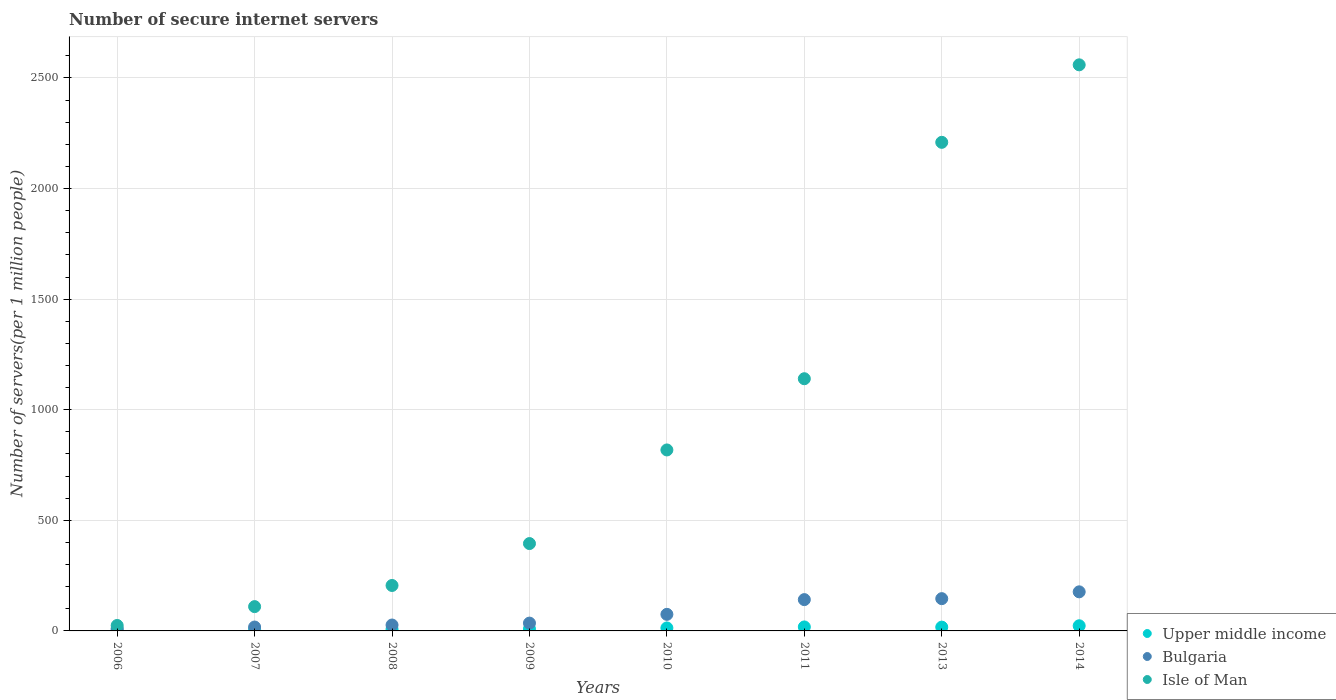How many different coloured dotlines are there?
Give a very brief answer. 3. What is the number of secure internet servers in Isle of Man in 2010?
Your answer should be compact. 818.24. Across all years, what is the maximum number of secure internet servers in Isle of Man?
Keep it short and to the point. 2559.48. Across all years, what is the minimum number of secure internet servers in Bulgaria?
Provide a succinct answer. 11.17. In which year was the number of secure internet servers in Isle of Man maximum?
Offer a very short reply. 2014. What is the total number of secure internet servers in Bulgaria in the graph?
Provide a succinct answer. 629.88. What is the difference between the number of secure internet servers in Bulgaria in 2011 and that in 2014?
Provide a short and direct response. -35.19. What is the difference between the number of secure internet servers in Bulgaria in 2013 and the number of secure internet servers in Upper middle income in 2008?
Your answer should be compact. 137.87. What is the average number of secure internet servers in Upper middle income per year?
Give a very brief answer. 12.51. In the year 2014, what is the difference between the number of secure internet servers in Bulgaria and number of secure internet servers in Isle of Man?
Give a very brief answer. -2382.77. What is the ratio of the number of secure internet servers in Upper middle income in 2006 to that in 2014?
Offer a terse response. 0.2. What is the difference between the highest and the second highest number of secure internet servers in Isle of Man?
Your answer should be very brief. 350.42. What is the difference between the highest and the lowest number of secure internet servers in Upper middle income?
Ensure brevity in your answer.  18.7. Is the sum of the number of secure internet servers in Isle of Man in 2007 and 2009 greater than the maximum number of secure internet servers in Bulgaria across all years?
Offer a terse response. Yes. Is it the case that in every year, the sum of the number of secure internet servers in Upper middle income and number of secure internet servers in Isle of Man  is greater than the number of secure internet servers in Bulgaria?
Make the answer very short. Yes. Is the number of secure internet servers in Isle of Man strictly greater than the number of secure internet servers in Upper middle income over the years?
Ensure brevity in your answer.  Yes. How many dotlines are there?
Provide a succinct answer. 3. How many years are there in the graph?
Make the answer very short. 8. What is the difference between two consecutive major ticks on the Y-axis?
Ensure brevity in your answer.  500. Does the graph contain any zero values?
Provide a succinct answer. No. Where does the legend appear in the graph?
Give a very brief answer. Bottom right. What is the title of the graph?
Provide a short and direct response. Number of secure internet servers. What is the label or title of the X-axis?
Give a very brief answer. Years. What is the label or title of the Y-axis?
Ensure brevity in your answer.  Number of servers(per 1 million people). What is the Number of servers(per 1 million people) of Upper middle income in 2006?
Offer a terse response. 4.6. What is the Number of servers(per 1 million people) in Bulgaria in 2006?
Your response must be concise. 11.17. What is the Number of servers(per 1 million people) of Isle of Man in 2006?
Offer a very short reply. 24.66. What is the Number of servers(per 1 million people) in Upper middle income in 2007?
Keep it short and to the point. 6.38. What is the Number of servers(per 1 million people) of Bulgaria in 2007?
Your answer should be very brief. 17.63. What is the Number of servers(per 1 million people) of Isle of Man in 2007?
Keep it short and to the point. 109.87. What is the Number of servers(per 1 million people) of Upper middle income in 2008?
Keep it short and to the point. 8.03. What is the Number of servers(per 1 million people) in Bulgaria in 2008?
Offer a terse response. 26.69. What is the Number of servers(per 1 million people) in Isle of Man in 2008?
Give a very brief answer. 205.47. What is the Number of servers(per 1 million people) of Upper middle income in 2009?
Keep it short and to the point. 9.16. What is the Number of servers(per 1 million people) in Bulgaria in 2009?
Your response must be concise. 35.33. What is the Number of servers(per 1 million people) in Isle of Man in 2009?
Your answer should be compact. 394.98. What is the Number of servers(per 1 million people) of Upper middle income in 2010?
Offer a terse response. 13.42. What is the Number of servers(per 1 million people) of Bulgaria in 2010?
Ensure brevity in your answer.  74.91. What is the Number of servers(per 1 million people) of Isle of Man in 2010?
Offer a very short reply. 818.24. What is the Number of servers(per 1 million people) of Upper middle income in 2011?
Give a very brief answer. 18.02. What is the Number of servers(per 1 million people) in Bulgaria in 2011?
Provide a succinct answer. 141.53. What is the Number of servers(per 1 million people) in Isle of Man in 2011?
Provide a succinct answer. 1140.25. What is the Number of servers(per 1 million people) of Upper middle income in 2013?
Make the answer very short. 17.16. What is the Number of servers(per 1 million people) in Bulgaria in 2013?
Offer a very short reply. 145.9. What is the Number of servers(per 1 million people) in Isle of Man in 2013?
Make the answer very short. 2209.06. What is the Number of servers(per 1 million people) in Upper middle income in 2014?
Offer a terse response. 23.3. What is the Number of servers(per 1 million people) in Bulgaria in 2014?
Keep it short and to the point. 176.72. What is the Number of servers(per 1 million people) of Isle of Man in 2014?
Give a very brief answer. 2559.48. Across all years, what is the maximum Number of servers(per 1 million people) in Upper middle income?
Ensure brevity in your answer.  23.3. Across all years, what is the maximum Number of servers(per 1 million people) in Bulgaria?
Your answer should be compact. 176.72. Across all years, what is the maximum Number of servers(per 1 million people) of Isle of Man?
Ensure brevity in your answer.  2559.48. Across all years, what is the minimum Number of servers(per 1 million people) in Upper middle income?
Give a very brief answer. 4.6. Across all years, what is the minimum Number of servers(per 1 million people) in Bulgaria?
Provide a succinct answer. 11.17. Across all years, what is the minimum Number of servers(per 1 million people) of Isle of Man?
Keep it short and to the point. 24.66. What is the total Number of servers(per 1 million people) in Upper middle income in the graph?
Make the answer very short. 100.08. What is the total Number of servers(per 1 million people) in Bulgaria in the graph?
Provide a short and direct response. 629.88. What is the total Number of servers(per 1 million people) of Isle of Man in the graph?
Provide a succinct answer. 7462.02. What is the difference between the Number of servers(per 1 million people) in Upper middle income in 2006 and that in 2007?
Your answer should be very brief. -1.78. What is the difference between the Number of servers(per 1 million people) in Bulgaria in 2006 and that in 2007?
Ensure brevity in your answer.  -6.46. What is the difference between the Number of servers(per 1 million people) in Isle of Man in 2006 and that in 2007?
Give a very brief answer. -85.21. What is the difference between the Number of servers(per 1 million people) of Upper middle income in 2006 and that in 2008?
Provide a succinct answer. -3.43. What is the difference between the Number of servers(per 1 million people) in Bulgaria in 2006 and that in 2008?
Your answer should be very brief. -15.52. What is the difference between the Number of servers(per 1 million people) of Isle of Man in 2006 and that in 2008?
Offer a terse response. -180.81. What is the difference between the Number of servers(per 1 million people) of Upper middle income in 2006 and that in 2009?
Keep it short and to the point. -4.56. What is the difference between the Number of servers(per 1 million people) of Bulgaria in 2006 and that in 2009?
Provide a short and direct response. -24.16. What is the difference between the Number of servers(per 1 million people) of Isle of Man in 2006 and that in 2009?
Provide a short and direct response. -370.32. What is the difference between the Number of servers(per 1 million people) in Upper middle income in 2006 and that in 2010?
Give a very brief answer. -8.82. What is the difference between the Number of servers(per 1 million people) of Bulgaria in 2006 and that in 2010?
Give a very brief answer. -63.74. What is the difference between the Number of servers(per 1 million people) in Isle of Man in 2006 and that in 2010?
Ensure brevity in your answer.  -793.59. What is the difference between the Number of servers(per 1 million people) of Upper middle income in 2006 and that in 2011?
Ensure brevity in your answer.  -13.42. What is the difference between the Number of servers(per 1 million people) in Bulgaria in 2006 and that in 2011?
Keep it short and to the point. -130.36. What is the difference between the Number of servers(per 1 million people) of Isle of Man in 2006 and that in 2011?
Your response must be concise. -1115.59. What is the difference between the Number of servers(per 1 million people) of Upper middle income in 2006 and that in 2013?
Offer a terse response. -12.56. What is the difference between the Number of servers(per 1 million people) in Bulgaria in 2006 and that in 2013?
Your response must be concise. -134.73. What is the difference between the Number of servers(per 1 million people) in Isle of Man in 2006 and that in 2013?
Your answer should be very brief. -2184.41. What is the difference between the Number of servers(per 1 million people) of Upper middle income in 2006 and that in 2014?
Your answer should be compact. -18.7. What is the difference between the Number of servers(per 1 million people) in Bulgaria in 2006 and that in 2014?
Ensure brevity in your answer.  -165.55. What is the difference between the Number of servers(per 1 million people) of Isle of Man in 2006 and that in 2014?
Your response must be concise. -2534.82. What is the difference between the Number of servers(per 1 million people) of Upper middle income in 2007 and that in 2008?
Make the answer very short. -1.65. What is the difference between the Number of servers(per 1 million people) of Bulgaria in 2007 and that in 2008?
Make the answer very short. -9.07. What is the difference between the Number of servers(per 1 million people) of Isle of Man in 2007 and that in 2008?
Give a very brief answer. -95.6. What is the difference between the Number of servers(per 1 million people) of Upper middle income in 2007 and that in 2009?
Make the answer very short. -2.78. What is the difference between the Number of servers(per 1 million people) of Bulgaria in 2007 and that in 2009?
Keep it short and to the point. -17.7. What is the difference between the Number of servers(per 1 million people) in Isle of Man in 2007 and that in 2009?
Provide a short and direct response. -285.11. What is the difference between the Number of servers(per 1 million people) in Upper middle income in 2007 and that in 2010?
Keep it short and to the point. -7.04. What is the difference between the Number of servers(per 1 million people) in Bulgaria in 2007 and that in 2010?
Your response must be concise. -57.28. What is the difference between the Number of servers(per 1 million people) of Isle of Man in 2007 and that in 2010?
Provide a succinct answer. -708.37. What is the difference between the Number of servers(per 1 million people) in Upper middle income in 2007 and that in 2011?
Provide a succinct answer. -11.64. What is the difference between the Number of servers(per 1 million people) of Bulgaria in 2007 and that in 2011?
Ensure brevity in your answer.  -123.9. What is the difference between the Number of servers(per 1 million people) of Isle of Man in 2007 and that in 2011?
Give a very brief answer. -1030.38. What is the difference between the Number of servers(per 1 million people) in Upper middle income in 2007 and that in 2013?
Your answer should be very brief. -10.78. What is the difference between the Number of servers(per 1 million people) in Bulgaria in 2007 and that in 2013?
Keep it short and to the point. -128.28. What is the difference between the Number of servers(per 1 million people) of Isle of Man in 2007 and that in 2013?
Give a very brief answer. -2099.19. What is the difference between the Number of servers(per 1 million people) in Upper middle income in 2007 and that in 2014?
Make the answer very short. -16.92. What is the difference between the Number of servers(per 1 million people) of Bulgaria in 2007 and that in 2014?
Give a very brief answer. -159.09. What is the difference between the Number of servers(per 1 million people) of Isle of Man in 2007 and that in 2014?
Keep it short and to the point. -2449.61. What is the difference between the Number of servers(per 1 million people) of Upper middle income in 2008 and that in 2009?
Give a very brief answer. -1.13. What is the difference between the Number of servers(per 1 million people) of Bulgaria in 2008 and that in 2009?
Provide a short and direct response. -8.64. What is the difference between the Number of servers(per 1 million people) in Isle of Man in 2008 and that in 2009?
Give a very brief answer. -189.51. What is the difference between the Number of servers(per 1 million people) of Upper middle income in 2008 and that in 2010?
Give a very brief answer. -5.39. What is the difference between the Number of servers(per 1 million people) of Bulgaria in 2008 and that in 2010?
Your answer should be very brief. -48.22. What is the difference between the Number of servers(per 1 million people) of Isle of Man in 2008 and that in 2010?
Provide a succinct answer. -612.77. What is the difference between the Number of servers(per 1 million people) in Upper middle income in 2008 and that in 2011?
Your response must be concise. -9.99. What is the difference between the Number of servers(per 1 million people) of Bulgaria in 2008 and that in 2011?
Give a very brief answer. -114.84. What is the difference between the Number of servers(per 1 million people) in Isle of Man in 2008 and that in 2011?
Provide a succinct answer. -934.78. What is the difference between the Number of servers(per 1 million people) of Upper middle income in 2008 and that in 2013?
Offer a very short reply. -9.12. What is the difference between the Number of servers(per 1 million people) of Bulgaria in 2008 and that in 2013?
Keep it short and to the point. -119.21. What is the difference between the Number of servers(per 1 million people) of Isle of Man in 2008 and that in 2013?
Offer a very short reply. -2003.59. What is the difference between the Number of servers(per 1 million people) in Upper middle income in 2008 and that in 2014?
Offer a terse response. -15.27. What is the difference between the Number of servers(per 1 million people) in Bulgaria in 2008 and that in 2014?
Your answer should be very brief. -150.02. What is the difference between the Number of servers(per 1 million people) in Isle of Man in 2008 and that in 2014?
Keep it short and to the point. -2354.01. What is the difference between the Number of servers(per 1 million people) of Upper middle income in 2009 and that in 2010?
Offer a terse response. -4.26. What is the difference between the Number of servers(per 1 million people) of Bulgaria in 2009 and that in 2010?
Provide a short and direct response. -39.58. What is the difference between the Number of servers(per 1 million people) in Isle of Man in 2009 and that in 2010?
Your answer should be very brief. -423.26. What is the difference between the Number of servers(per 1 million people) of Upper middle income in 2009 and that in 2011?
Your answer should be very brief. -8.86. What is the difference between the Number of servers(per 1 million people) in Bulgaria in 2009 and that in 2011?
Keep it short and to the point. -106.2. What is the difference between the Number of servers(per 1 million people) of Isle of Man in 2009 and that in 2011?
Make the answer very short. -745.27. What is the difference between the Number of servers(per 1 million people) of Upper middle income in 2009 and that in 2013?
Offer a terse response. -7.99. What is the difference between the Number of servers(per 1 million people) of Bulgaria in 2009 and that in 2013?
Keep it short and to the point. -110.57. What is the difference between the Number of servers(per 1 million people) in Isle of Man in 2009 and that in 2013?
Keep it short and to the point. -1814.08. What is the difference between the Number of servers(per 1 million people) in Upper middle income in 2009 and that in 2014?
Offer a terse response. -14.14. What is the difference between the Number of servers(per 1 million people) of Bulgaria in 2009 and that in 2014?
Provide a succinct answer. -141.39. What is the difference between the Number of servers(per 1 million people) in Isle of Man in 2009 and that in 2014?
Ensure brevity in your answer.  -2164.5. What is the difference between the Number of servers(per 1 million people) of Upper middle income in 2010 and that in 2011?
Your answer should be compact. -4.6. What is the difference between the Number of servers(per 1 million people) in Bulgaria in 2010 and that in 2011?
Make the answer very short. -66.62. What is the difference between the Number of servers(per 1 million people) of Isle of Man in 2010 and that in 2011?
Offer a terse response. -322.01. What is the difference between the Number of servers(per 1 million people) of Upper middle income in 2010 and that in 2013?
Provide a succinct answer. -3.73. What is the difference between the Number of servers(per 1 million people) of Bulgaria in 2010 and that in 2013?
Ensure brevity in your answer.  -70.99. What is the difference between the Number of servers(per 1 million people) in Isle of Man in 2010 and that in 2013?
Keep it short and to the point. -1390.82. What is the difference between the Number of servers(per 1 million people) in Upper middle income in 2010 and that in 2014?
Give a very brief answer. -9.88. What is the difference between the Number of servers(per 1 million people) of Bulgaria in 2010 and that in 2014?
Make the answer very short. -101.81. What is the difference between the Number of servers(per 1 million people) of Isle of Man in 2010 and that in 2014?
Give a very brief answer. -1741.24. What is the difference between the Number of servers(per 1 million people) of Upper middle income in 2011 and that in 2013?
Your answer should be compact. 0.86. What is the difference between the Number of servers(per 1 million people) in Bulgaria in 2011 and that in 2013?
Your answer should be very brief. -4.37. What is the difference between the Number of servers(per 1 million people) of Isle of Man in 2011 and that in 2013?
Give a very brief answer. -1068.81. What is the difference between the Number of servers(per 1 million people) in Upper middle income in 2011 and that in 2014?
Ensure brevity in your answer.  -5.28. What is the difference between the Number of servers(per 1 million people) of Bulgaria in 2011 and that in 2014?
Your response must be concise. -35.19. What is the difference between the Number of servers(per 1 million people) of Isle of Man in 2011 and that in 2014?
Provide a succinct answer. -1419.23. What is the difference between the Number of servers(per 1 million people) in Upper middle income in 2013 and that in 2014?
Your response must be concise. -6.14. What is the difference between the Number of servers(per 1 million people) of Bulgaria in 2013 and that in 2014?
Keep it short and to the point. -30.81. What is the difference between the Number of servers(per 1 million people) of Isle of Man in 2013 and that in 2014?
Provide a succinct answer. -350.42. What is the difference between the Number of servers(per 1 million people) in Upper middle income in 2006 and the Number of servers(per 1 million people) in Bulgaria in 2007?
Offer a terse response. -13.03. What is the difference between the Number of servers(per 1 million people) in Upper middle income in 2006 and the Number of servers(per 1 million people) in Isle of Man in 2007?
Give a very brief answer. -105.27. What is the difference between the Number of servers(per 1 million people) in Bulgaria in 2006 and the Number of servers(per 1 million people) in Isle of Man in 2007?
Provide a succinct answer. -98.7. What is the difference between the Number of servers(per 1 million people) of Upper middle income in 2006 and the Number of servers(per 1 million people) of Bulgaria in 2008?
Keep it short and to the point. -22.09. What is the difference between the Number of servers(per 1 million people) in Upper middle income in 2006 and the Number of servers(per 1 million people) in Isle of Man in 2008?
Your answer should be compact. -200.87. What is the difference between the Number of servers(per 1 million people) in Bulgaria in 2006 and the Number of servers(per 1 million people) in Isle of Man in 2008?
Your answer should be very brief. -194.3. What is the difference between the Number of servers(per 1 million people) of Upper middle income in 2006 and the Number of servers(per 1 million people) of Bulgaria in 2009?
Ensure brevity in your answer.  -30.73. What is the difference between the Number of servers(per 1 million people) of Upper middle income in 2006 and the Number of servers(per 1 million people) of Isle of Man in 2009?
Offer a terse response. -390.38. What is the difference between the Number of servers(per 1 million people) in Bulgaria in 2006 and the Number of servers(per 1 million people) in Isle of Man in 2009?
Your answer should be compact. -383.81. What is the difference between the Number of servers(per 1 million people) in Upper middle income in 2006 and the Number of servers(per 1 million people) in Bulgaria in 2010?
Keep it short and to the point. -70.31. What is the difference between the Number of servers(per 1 million people) in Upper middle income in 2006 and the Number of servers(per 1 million people) in Isle of Man in 2010?
Provide a succinct answer. -813.64. What is the difference between the Number of servers(per 1 million people) of Bulgaria in 2006 and the Number of servers(per 1 million people) of Isle of Man in 2010?
Ensure brevity in your answer.  -807.07. What is the difference between the Number of servers(per 1 million people) in Upper middle income in 2006 and the Number of servers(per 1 million people) in Bulgaria in 2011?
Make the answer very short. -136.93. What is the difference between the Number of servers(per 1 million people) of Upper middle income in 2006 and the Number of servers(per 1 million people) of Isle of Man in 2011?
Make the answer very short. -1135.65. What is the difference between the Number of servers(per 1 million people) of Bulgaria in 2006 and the Number of servers(per 1 million people) of Isle of Man in 2011?
Make the answer very short. -1129.08. What is the difference between the Number of servers(per 1 million people) of Upper middle income in 2006 and the Number of servers(per 1 million people) of Bulgaria in 2013?
Keep it short and to the point. -141.3. What is the difference between the Number of servers(per 1 million people) in Upper middle income in 2006 and the Number of servers(per 1 million people) in Isle of Man in 2013?
Offer a terse response. -2204.46. What is the difference between the Number of servers(per 1 million people) in Bulgaria in 2006 and the Number of servers(per 1 million people) in Isle of Man in 2013?
Make the answer very short. -2197.89. What is the difference between the Number of servers(per 1 million people) of Upper middle income in 2006 and the Number of servers(per 1 million people) of Bulgaria in 2014?
Keep it short and to the point. -172.12. What is the difference between the Number of servers(per 1 million people) of Upper middle income in 2006 and the Number of servers(per 1 million people) of Isle of Man in 2014?
Provide a short and direct response. -2554.88. What is the difference between the Number of servers(per 1 million people) of Bulgaria in 2006 and the Number of servers(per 1 million people) of Isle of Man in 2014?
Offer a terse response. -2548.31. What is the difference between the Number of servers(per 1 million people) of Upper middle income in 2007 and the Number of servers(per 1 million people) of Bulgaria in 2008?
Give a very brief answer. -20.31. What is the difference between the Number of servers(per 1 million people) in Upper middle income in 2007 and the Number of servers(per 1 million people) in Isle of Man in 2008?
Provide a short and direct response. -199.09. What is the difference between the Number of servers(per 1 million people) in Bulgaria in 2007 and the Number of servers(per 1 million people) in Isle of Man in 2008?
Give a very brief answer. -187.84. What is the difference between the Number of servers(per 1 million people) of Upper middle income in 2007 and the Number of servers(per 1 million people) of Bulgaria in 2009?
Your answer should be compact. -28.95. What is the difference between the Number of servers(per 1 million people) of Upper middle income in 2007 and the Number of servers(per 1 million people) of Isle of Man in 2009?
Your response must be concise. -388.6. What is the difference between the Number of servers(per 1 million people) in Bulgaria in 2007 and the Number of servers(per 1 million people) in Isle of Man in 2009?
Your response must be concise. -377.36. What is the difference between the Number of servers(per 1 million people) of Upper middle income in 2007 and the Number of servers(per 1 million people) of Bulgaria in 2010?
Your response must be concise. -68.53. What is the difference between the Number of servers(per 1 million people) of Upper middle income in 2007 and the Number of servers(per 1 million people) of Isle of Man in 2010?
Provide a short and direct response. -811.86. What is the difference between the Number of servers(per 1 million people) of Bulgaria in 2007 and the Number of servers(per 1 million people) of Isle of Man in 2010?
Provide a short and direct response. -800.62. What is the difference between the Number of servers(per 1 million people) in Upper middle income in 2007 and the Number of servers(per 1 million people) in Bulgaria in 2011?
Offer a terse response. -135.15. What is the difference between the Number of servers(per 1 million people) of Upper middle income in 2007 and the Number of servers(per 1 million people) of Isle of Man in 2011?
Provide a succinct answer. -1133.87. What is the difference between the Number of servers(per 1 million people) in Bulgaria in 2007 and the Number of servers(per 1 million people) in Isle of Man in 2011?
Give a very brief answer. -1122.62. What is the difference between the Number of servers(per 1 million people) of Upper middle income in 2007 and the Number of servers(per 1 million people) of Bulgaria in 2013?
Make the answer very short. -139.52. What is the difference between the Number of servers(per 1 million people) in Upper middle income in 2007 and the Number of servers(per 1 million people) in Isle of Man in 2013?
Your response must be concise. -2202.68. What is the difference between the Number of servers(per 1 million people) in Bulgaria in 2007 and the Number of servers(per 1 million people) in Isle of Man in 2013?
Ensure brevity in your answer.  -2191.44. What is the difference between the Number of servers(per 1 million people) in Upper middle income in 2007 and the Number of servers(per 1 million people) in Bulgaria in 2014?
Your answer should be compact. -170.34. What is the difference between the Number of servers(per 1 million people) of Upper middle income in 2007 and the Number of servers(per 1 million people) of Isle of Man in 2014?
Offer a terse response. -2553.1. What is the difference between the Number of servers(per 1 million people) of Bulgaria in 2007 and the Number of servers(per 1 million people) of Isle of Man in 2014?
Provide a short and direct response. -2541.86. What is the difference between the Number of servers(per 1 million people) in Upper middle income in 2008 and the Number of servers(per 1 million people) in Bulgaria in 2009?
Provide a short and direct response. -27.29. What is the difference between the Number of servers(per 1 million people) in Upper middle income in 2008 and the Number of servers(per 1 million people) in Isle of Man in 2009?
Your response must be concise. -386.95. What is the difference between the Number of servers(per 1 million people) of Bulgaria in 2008 and the Number of servers(per 1 million people) of Isle of Man in 2009?
Provide a succinct answer. -368.29. What is the difference between the Number of servers(per 1 million people) of Upper middle income in 2008 and the Number of servers(per 1 million people) of Bulgaria in 2010?
Your answer should be very brief. -66.87. What is the difference between the Number of servers(per 1 million people) of Upper middle income in 2008 and the Number of servers(per 1 million people) of Isle of Man in 2010?
Offer a terse response. -810.21. What is the difference between the Number of servers(per 1 million people) of Bulgaria in 2008 and the Number of servers(per 1 million people) of Isle of Man in 2010?
Your answer should be very brief. -791.55. What is the difference between the Number of servers(per 1 million people) of Upper middle income in 2008 and the Number of servers(per 1 million people) of Bulgaria in 2011?
Your response must be concise. -133.49. What is the difference between the Number of servers(per 1 million people) of Upper middle income in 2008 and the Number of servers(per 1 million people) of Isle of Man in 2011?
Keep it short and to the point. -1132.22. What is the difference between the Number of servers(per 1 million people) of Bulgaria in 2008 and the Number of servers(per 1 million people) of Isle of Man in 2011?
Keep it short and to the point. -1113.56. What is the difference between the Number of servers(per 1 million people) of Upper middle income in 2008 and the Number of servers(per 1 million people) of Bulgaria in 2013?
Ensure brevity in your answer.  -137.87. What is the difference between the Number of servers(per 1 million people) of Upper middle income in 2008 and the Number of servers(per 1 million people) of Isle of Man in 2013?
Offer a very short reply. -2201.03. What is the difference between the Number of servers(per 1 million people) of Bulgaria in 2008 and the Number of servers(per 1 million people) of Isle of Man in 2013?
Provide a succinct answer. -2182.37. What is the difference between the Number of servers(per 1 million people) of Upper middle income in 2008 and the Number of servers(per 1 million people) of Bulgaria in 2014?
Keep it short and to the point. -168.68. What is the difference between the Number of servers(per 1 million people) in Upper middle income in 2008 and the Number of servers(per 1 million people) in Isle of Man in 2014?
Your answer should be compact. -2551.45. What is the difference between the Number of servers(per 1 million people) in Bulgaria in 2008 and the Number of servers(per 1 million people) in Isle of Man in 2014?
Provide a succinct answer. -2532.79. What is the difference between the Number of servers(per 1 million people) of Upper middle income in 2009 and the Number of servers(per 1 million people) of Bulgaria in 2010?
Provide a succinct answer. -65.75. What is the difference between the Number of servers(per 1 million people) in Upper middle income in 2009 and the Number of servers(per 1 million people) in Isle of Man in 2010?
Ensure brevity in your answer.  -809.08. What is the difference between the Number of servers(per 1 million people) of Bulgaria in 2009 and the Number of servers(per 1 million people) of Isle of Man in 2010?
Your answer should be compact. -782.91. What is the difference between the Number of servers(per 1 million people) in Upper middle income in 2009 and the Number of servers(per 1 million people) in Bulgaria in 2011?
Provide a succinct answer. -132.37. What is the difference between the Number of servers(per 1 million people) in Upper middle income in 2009 and the Number of servers(per 1 million people) in Isle of Man in 2011?
Provide a short and direct response. -1131.09. What is the difference between the Number of servers(per 1 million people) of Bulgaria in 2009 and the Number of servers(per 1 million people) of Isle of Man in 2011?
Provide a succinct answer. -1104.92. What is the difference between the Number of servers(per 1 million people) in Upper middle income in 2009 and the Number of servers(per 1 million people) in Bulgaria in 2013?
Ensure brevity in your answer.  -136.74. What is the difference between the Number of servers(per 1 million people) in Upper middle income in 2009 and the Number of servers(per 1 million people) in Isle of Man in 2013?
Provide a short and direct response. -2199.9. What is the difference between the Number of servers(per 1 million people) of Bulgaria in 2009 and the Number of servers(per 1 million people) of Isle of Man in 2013?
Give a very brief answer. -2173.73. What is the difference between the Number of servers(per 1 million people) in Upper middle income in 2009 and the Number of servers(per 1 million people) in Bulgaria in 2014?
Offer a very short reply. -167.55. What is the difference between the Number of servers(per 1 million people) in Upper middle income in 2009 and the Number of servers(per 1 million people) in Isle of Man in 2014?
Give a very brief answer. -2550.32. What is the difference between the Number of servers(per 1 million people) in Bulgaria in 2009 and the Number of servers(per 1 million people) in Isle of Man in 2014?
Your answer should be very brief. -2524.15. What is the difference between the Number of servers(per 1 million people) of Upper middle income in 2010 and the Number of servers(per 1 million people) of Bulgaria in 2011?
Offer a very short reply. -128.11. What is the difference between the Number of servers(per 1 million people) in Upper middle income in 2010 and the Number of servers(per 1 million people) in Isle of Man in 2011?
Your response must be concise. -1126.83. What is the difference between the Number of servers(per 1 million people) of Bulgaria in 2010 and the Number of servers(per 1 million people) of Isle of Man in 2011?
Your response must be concise. -1065.34. What is the difference between the Number of servers(per 1 million people) of Upper middle income in 2010 and the Number of servers(per 1 million people) of Bulgaria in 2013?
Make the answer very short. -132.48. What is the difference between the Number of servers(per 1 million people) in Upper middle income in 2010 and the Number of servers(per 1 million people) in Isle of Man in 2013?
Keep it short and to the point. -2195.64. What is the difference between the Number of servers(per 1 million people) in Bulgaria in 2010 and the Number of servers(per 1 million people) in Isle of Man in 2013?
Make the answer very short. -2134.15. What is the difference between the Number of servers(per 1 million people) in Upper middle income in 2010 and the Number of servers(per 1 million people) in Bulgaria in 2014?
Your answer should be compact. -163.29. What is the difference between the Number of servers(per 1 million people) in Upper middle income in 2010 and the Number of servers(per 1 million people) in Isle of Man in 2014?
Provide a short and direct response. -2546.06. What is the difference between the Number of servers(per 1 million people) of Bulgaria in 2010 and the Number of servers(per 1 million people) of Isle of Man in 2014?
Provide a succinct answer. -2484.57. What is the difference between the Number of servers(per 1 million people) in Upper middle income in 2011 and the Number of servers(per 1 million people) in Bulgaria in 2013?
Offer a very short reply. -127.88. What is the difference between the Number of servers(per 1 million people) in Upper middle income in 2011 and the Number of servers(per 1 million people) in Isle of Man in 2013?
Offer a terse response. -2191.04. What is the difference between the Number of servers(per 1 million people) of Bulgaria in 2011 and the Number of servers(per 1 million people) of Isle of Man in 2013?
Provide a succinct answer. -2067.53. What is the difference between the Number of servers(per 1 million people) in Upper middle income in 2011 and the Number of servers(per 1 million people) in Bulgaria in 2014?
Your answer should be compact. -158.7. What is the difference between the Number of servers(per 1 million people) in Upper middle income in 2011 and the Number of servers(per 1 million people) in Isle of Man in 2014?
Provide a succinct answer. -2541.46. What is the difference between the Number of servers(per 1 million people) of Bulgaria in 2011 and the Number of servers(per 1 million people) of Isle of Man in 2014?
Give a very brief answer. -2417.95. What is the difference between the Number of servers(per 1 million people) of Upper middle income in 2013 and the Number of servers(per 1 million people) of Bulgaria in 2014?
Offer a terse response. -159.56. What is the difference between the Number of servers(per 1 million people) in Upper middle income in 2013 and the Number of servers(per 1 million people) in Isle of Man in 2014?
Give a very brief answer. -2542.33. What is the difference between the Number of servers(per 1 million people) of Bulgaria in 2013 and the Number of servers(per 1 million people) of Isle of Man in 2014?
Give a very brief answer. -2413.58. What is the average Number of servers(per 1 million people) in Upper middle income per year?
Make the answer very short. 12.51. What is the average Number of servers(per 1 million people) in Bulgaria per year?
Your answer should be compact. 78.73. What is the average Number of servers(per 1 million people) of Isle of Man per year?
Provide a succinct answer. 932.75. In the year 2006, what is the difference between the Number of servers(per 1 million people) of Upper middle income and Number of servers(per 1 million people) of Bulgaria?
Provide a short and direct response. -6.57. In the year 2006, what is the difference between the Number of servers(per 1 million people) in Upper middle income and Number of servers(per 1 million people) in Isle of Man?
Your response must be concise. -20.06. In the year 2006, what is the difference between the Number of servers(per 1 million people) of Bulgaria and Number of servers(per 1 million people) of Isle of Man?
Offer a terse response. -13.49. In the year 2007, what is the difference between the Number of servers(per 1 million people) of Upper middle income and Number of servers(per 1 million people) of Bulgaria?
Your answer should be compact. -11.25. In the year 2007, what is the difference between the Number of servers(per 1 million people) of Upper middle income and Number of servers(per 1 million people) of Isle of Man?
Offer a terse response. -103.49. In the year 2007, what is the difference between the Number of servers(per 1 million people) of Bulgaria and Number of servers(per 1 million people) of Isle of Man?
Provide a succinct answer. -92.24. In the year 2008, what is the difference between the Number of servers(per 1 million people) in Upper middle income and Number of servers(per 1 million people) in Bulgaria?
Give a very brief answer. -18.66. In the year 2008, what is the difference between the Number of servers(per 1 million people) of Upper middle income and Number of servers(per 1 million people) of Isle of Man?
Provide a succinct answer. -197.44. In the year 2008, what is the difference between the Number of servers(per 1 million people) in Bulgaria and Number of servers(per 1 million people) in Isle of Man?
Give a very brief answer. -178.78. In the year 2009, what is the difference between the Number of servers(per 1 million people) of Upper middle income and Number of servers(per 1 million people) of Bulgaria?
Provide a short and direct response. -26.17. In the year 2009, what is the difference between the Number of servers(per 1 million people) in Upper middle income and Number of servers(per 1 million people) in Isle of Man?
Offer a very short reply. -385.82. In the year 2009, what is the difference between the Number of servers(per 1 million people) of Bulgaria and Number of servers(per 1 million people) of Isle of Man?
Provide a short and direct response. -359.65. In the year 2010, what is the difference between the Number of servers(per 1 million people) of Upper middle income and Number of servers(per 1 million people) of Bulgaria?
Your answer should be very brief. -61.49. In the year 2010, what is the difference between the Number of servers(per 1 million people) of Upper middle income and Number of servers(per 1 million people) of Isle of Man?
Provide a succinct answer. -804.82. In the year 2010, what is the difference between the Number of servers(per 1 million people) of Bulgaria and Number of servers(per 1 million people) of Isle of Man?
Make the answer very short. -743.33. In the year 2011, what is the difference between the Number of servers(per 1 million people) of Upper middle income and Number of servers(per 1 million people) of Bulgaria?
Ensure brevity in your answer.  -123.51. In the year 2011, what is the difference between the Number of servers(per 1 million people) in Upper middle income and Number of servers(per 1 million people) in Isle of Man?
Give a very brief answer. -1122.23. In the year 2011, what is the difference between the Number of servers(per 1 million people) of Bulgaria and Number of servers(per 1 million people) of Isle of Man?
Ensure brevity in your answer.  -998.72. In the year 2013, what is the difference between the Number of servers(per 1 million people) in Upper middle income and Number of servers(per 1 million people) in Bulgaria?
Provide a succinct answer. -128.75. In the year 2013, what is the difference between the Number of servers(per 1 million people) of Upper middle income and Number of servers(per 1 million people) of Isle of Man?
Keep it short and to the point. -2191.91. In the year 2013, what is the difference between the Number of servers(per 1 million people) in Bulgaria and Number of servers(per 1 million people) in Isle of Man?
Your answer should be very brief. -2063.16. In the year 2014, what is the difference between the Number of servers(per 1 million people) of Upper middle income and Number of servers(per 1 million people) of Bulgaria?
Keep it short and to the point. -153.42. In the year 2014, what is the difference between the Number of servers(per 1 million people) of Upper middle income and Number of servers(per 1 million people) of Isle of Man?
Your answer should be very brief. -2536.18. In the year 2014, what is the difference between the Number of servers(per 1 million people) in Bulgaria and Number of servers(per 1 million people) in Isle of Man?
Keep it short and to the point. -2382.77. What is the ratio of the Number of servers(per 1 million people) in Upper middle income in 2006 to that in 2007?
Offer a terse response. 0.72. What is the ratio of the Number of servers(per 1 million people) in Bulgaria in 2006 to that in 2007?
Keep it short and to the point. 0.63. What is the ratio of the Number of servers(per 1 million people) in Isle of Man in 2006 to that in 2007?
Offer a terse response. 0.22. What is the ratio of the Number of servers(per 1 million people) in Upper middle income in 2006 to that in 2008?
Give a very brief answer. 0.57. What is the ratio of the Number of servers(per 1 million people) of Bulgaria in 2006 to that in 2008?
Provide a short and direct response. 0.42. What is the ratio of the Number of servers(per 1 million people) of Isle of Man in 2006 to that in 2008?
Ensure brevity in your answer.  0.12. What is the ratio of the Number of servers(per 1 million people) of Upper middle income in 2006 to that in 2009?
Offer a very short reply. 0.5. What is the ratio of the Number of servers(per 1 million people) in Bulgaria in 2006 to that in 2009?
Your answer should be compact. 0.32. What is the ratio of the Number of servers(per 1 million people) in Isle of Man in 2006 to that in 2009?
Make the answer very short. 0.06. What is the ratio of the Number of servers(per 1 million people) of Upper middle income in 2006 to that in 2010?
Provide a succinct answer. 0.34. What is the ratio of the Number of servers(per 1 million people) of Bulgaria in 2006 to that in 2010?
Your answer should be very brief. 0.15. What is the ratio of the Number of servers(per 1 million people) of Isle of Man in 2006 to that in 2010?
Offer a very short reply. 0.03. What is the ratio of the Number of servers(per 1 million people) of Upper middle income in 2006 to that in 2011?
Your answer should be very brief. 0.26. What is the ratio of the Number of servers(per 1 million people) in Bulgaria in 2006 to that in 2011?
Make the answer very short. 0.08. What is the ratio of the Number of servers(per 1 million people) in Isle of Man in 2006 to that in 2011?
Keep it short and to the point. 0.02. What is the ratio of the Number of servers(per 1 million people) of Upper middle income in 2006 to that in 2013?
Offer a terse response. 0.27. What is the ratio of the Number of servers(per 1 million people) in Bulgaria in 2006 to that in 2013?
Provide a short and direct response. 0.08. What is the ratio of the Number of servers(per 1 million people) of Isle of Man in 2006 to that in 2013?
Your answer should be compact. 0.01. What is the ratio of the Number of servers(per 1 million people) of Upper middle income in 2006 to that in 2014?
Keep it short and to the point. 0.2. What is the ratio of the Number of servers(per 1 million people) in Bulgaria in 2006 to that in 2014?
Your answer should be compact. 0.06. What is the ratio of the Number of servers(per 1 million people) in Isle of Man in 2006 to that in 2014?
Offer a terse response. 0.01. What is the ratio of the Number of servers(per 1 million people) in Upper middle income in 2007 to that in 2008?
Your response must be concise. 0.79. What is the ratio of the Number of servers(per 1 million people) of Bulgaria in 2007 to that in 2008?
Offer a very short reply. 0.66. What is the ratio of the Number of servers(per 1 million people) of Isle of Man in 2007 to that in 2008?
Provide a succinct answer. 0.53. What is the ratio of the Number of servers(per 1 million people) of Upper middle income in 2007 to that in 2009?
Keep it short and to the point. 0.7. What is the ratio of the Number of servers(per 1 million people) of Bulgaria in 2007 to that in 2009?
Offer a terse response. 0.5. What is the ratio of the Number of servers(per 1 million people) in Isle of Man in 2007 to that in 2009?
Give a very brief answer. 0.28. What is the ratio of the Number of servers(per 1 million people) of Upper middle income in 2007 to that in 2010?
Ensure brevity in your answer.  0.48. What is the ratio of the Number of servers(per 1 million people) in Bulgaria in 2007 to that in 2010?
Provide a succinct answer. 0.24. What is the ratio of the Number of servers(per 1 million people) in Isle of Man in 2007 to that in 2010?
Provide a short and direct response. 0.13. What is the ratio of the Number of servers(per 1 million people) in Upper middle income in 2007 to that in 2011?
Offer a terse response. 0.35. What is the ratio of the Number of servers(per 1 million people) of Bulgaria in 2007 to that in 2011?
Your answer should be compact. 0.12. What is the ratio of the Number of servers(per 1 million people) in Isle of Man in 2007 to that in 2011?
Your answer should be very brief. 0.1. What is the ratio of the Number of servers(per 1 million people) of Upper middle income in 2007 to that in 2013?
Your answer should be very brief. 0.37. What is the ratio of the Number of servers(per 1 million people) of Bulgaria in 2007 to that in 2013?
Provide a succinct answer. 0.12. What is the ratio of the Number of servers(per 1 million people) of Isle of Man in 2007 to that in 2013?
Provide a short and direct response. 0.05. What is the ratio of the Number of servers(per 1 million people) in Upper middle income in 2007 to that in 2014?
Give a very brief answer. 0.27. What is the ratio of the Number of servers(per 1 million people) in Bulgaria in 2007 to that in 2014?
Give a very brief answer. 0.1. What is the ratio of the Number of servers(per 1 million people) of Isle of Man in 2007 to that in 2014?
Ensure brevity in your answer.  0.04. What is the ratio of the Number of servers(per 1 million people) in Upper middle income in 2008 to that in 2009?
Offer a very short reply. 0.88. What is the ratio of the Number of servers(per 1 million people) in Bulgaria in 2008 to that in 2009?
Provide a short and direct response. 0.76. What is the ratio of the Number of servers(per 1 million people) of Isle of Man in 2008 to that in 2009?
Ensure brevity in your answer.  0.52. What is the ratio of the Number of servers(per 1 million people) in Upper middle income in 2008 to that in 2010?
Your answer should be very brief. 0.6. What is the ratio of the Number of servers(per 1 million people) of Bulgaria in 2008 to that in 2010?
Ensure brevity in your answer.  0.36. What is the ratio of the Number of servers(per 1 million people) of Isle of Man in 2008 to that in 2010?
Your answer should be very brief. 0.25. What is the ratio of the Number of servers(per 1 million people) in Upper middle income in 2008 to that in 2011?
Your response must be concise. 0.45. What is the ratio of the Number of servers(per 1 million people) in Bulgaria in 2008 to that in 2011?
Your response must be concise. 0.19. What is the ratio of the Number of servers(per 1 million people) of Isle of Man in 2008 to that in 2011?
Provide a succinct answer. 0.18. What is the ratio of the Number of servers(per 1 million people) in Upper middle income in 2008 to that in 2013?
Keep it short and to the point. 0.47. What is the ratio of the Number of servers(per 1 million people) of Bulgaria in 2008 to that in 2013?
Your answer should be compact. 0.18. What is the ratio of the Number of servers(per 1 million people) in Isle of Man in 2008 to that in 2013?
Your answer should be compact. 0.09. What is the ratio of the Number of servers(per 1 million people) of Upper middle income in 2008 to that in 2014?
Your answer should be compact. 0.34. What is the ratio of the Number of servers(per 1 million people) in Bulgaria in 2008 to that in 2014?
Provide a succinct answer. 0.15. What is the ratio of the Number of servers(per 1 million people) of Isle of Man in 2008 to that in 2014?
Provide a succinct answer. 0.08. What is the ratio of the Number of servers(per 1 million people) of Upper middle income in 2009 to that in 2010?
Provide a short and direct response. 0.68. What is the ratio of the Number of servers(per 1 million people) in Bulgaria in 2009 to that in 2010?
Keep it short and to the point. 0.47. What is the ratio of the Number of servers(per 1 million people) of Isle of Man in 2009 to that in 2010?
Your response must be concise. 0.48. What is the ratio of the Number of servers(per 1 million people) of Upper middle income in 2009 to that in 2011?
Your answer should be compact. 0.51. What is the ratio of the Number of servers(per 1 million people) in Bulgaria in 2009 to that in 2011?
Keep it short and to the point. 0.25. What is the ratio of the Number of servers(per 1 million people) in Isle of Man in 2009 to that in 2011?
Make the answer very short. 0.35. What is the ratio of the Number of servers(per 1 million people) in Upper middle income in 2009 to that in 2013?
Ensure brevity in your answer.  0.53. What is the ratio of the Number of servers(per 1 million people) in Bulgaria in 2009 to that in 2013?
Provide a short and direct response. 0.24. What is the ratio of the Number of servers(per 1 million people) in Isle of Man in 2009 to that in 2013?
Make the answer very short. 0.18. What is the ratio of the Number of servers(per 1 million people) in Upper middle income in 2009 to that in 2014?
Your answer should be compact. 0.39. What is the ratio of the Number of servers(per 1 million people) of Bulgaria in 2009 to that in 2014?
Ensure brevity in your answer.  0.2. What is the ratio of the Number of servers(per 1 million people) of Isle of Man in 2009 to that in 2014?
Your answer should be compact. 0.15. What is the ratio of the Number of servers(per 1 million people) in Upper middle income in 2010 to that in 2011?
Ensure brevity in your answer.  0.74. What is the ratio of the Number of servers(per 1 million people) in Bulgaria in 2010 to that in 2011?
Offer a terse response. 0.53. What is the ratio of the Number of servers(per 1 million people) of Isle of Man in 2010 to that in 2011?
Make the answer very short. 0.72. What is the ratio of the Number of servers(per 1 million people) in Upper middle income in 2010 to that in 2013?
Your answer should be compact. 0.78. What is the ratio of the Number of servers(per 1 million people) in Bulgaria in 2010 to that in 2013?
Give a very brief answer. 0.51. What is the ratio of the Number of servers(per 1 million people) of Isle of Man in 2010 to that in 2013?
Your answer should be compact. 0.37. What is the ratio of the Number of servers(per 1 million people) of Upper middle income in 2010 to that in 2014?
Give a very brief answer. 0.58. What is the ratio of the Number of servers(per 1 million people) of Bulgaria in 2010 to that in 2014?
Make the answer very short. 0.42. What is the ratio of the Number of servers(per 1 million people) of Isle of Man in 2010 to that in 2014?
Ensure brevity in your answer.  0.32. What is the ratio of the Number of servers(per 1 million people) in Upper middle income in 2011 to that in 2013?
Give a very brief answer. 1.05. What is the ratio of the Number of servers(per 1 million people) of Isle of Man in 2011 to that in 2013?
Give a very brief answer. 0.52. What is the ratio of the Number of servers(per 1 million people) in Upper middle income in 2011 to that in 2014?
Your answer should be compact. 0.77. What is the ratio of the Number of servers(per 1 million people) of Bulgaria in 2011 to that in 2014?
Your answer should be very brief. 0.8. What is the ratio of the Number of servers(per 1 million people) of Isle of Man in 2011 to that in 2014?
Offer a very short reply. 0.45. What is the ratio of the Number of servers(per 1 million people) in Upper middle income in 2013 to that in 2014?
Offer a very short reply. 0.74. What is the ratio of the Number of servers(per 1 million people) in Bulgaria in 2013 to that in 2014?
Ensure brevity in your answer.  0.83. What is the ratio of the Number of servers(per 1 million people) of Isle of Man in 2013 to that in 2014?
Your response must be concise. 0.86. What is the difference between the highest and the second highest Number of servers(per 1 million people) in Upper middle income?
Ensure brevity in your answer.  5.28. What is the difference between the highest and the second highest Number of servers(per 1 million people) of Bulgaria?
Offer a terse response. 30.81. What is the difference between the highest and the second highest Number of servers(per 1 million people) in Isle of Man?
Keep it short and to the point. 350.42. What is the difference between the highest and the lowest Number of servers(per 1 million people) in Upper middle income?
Give a very brief answer. 18.7. What is the difference between the highest and the lowest Number of servers(per 1 million people) in Bulgaria?
Your answer should be compact. 165.55. What is the difference between the highest and the lowest Number of servers(per 1 million people) of Isle of Man?
Your response must be concise. 2534.82. 